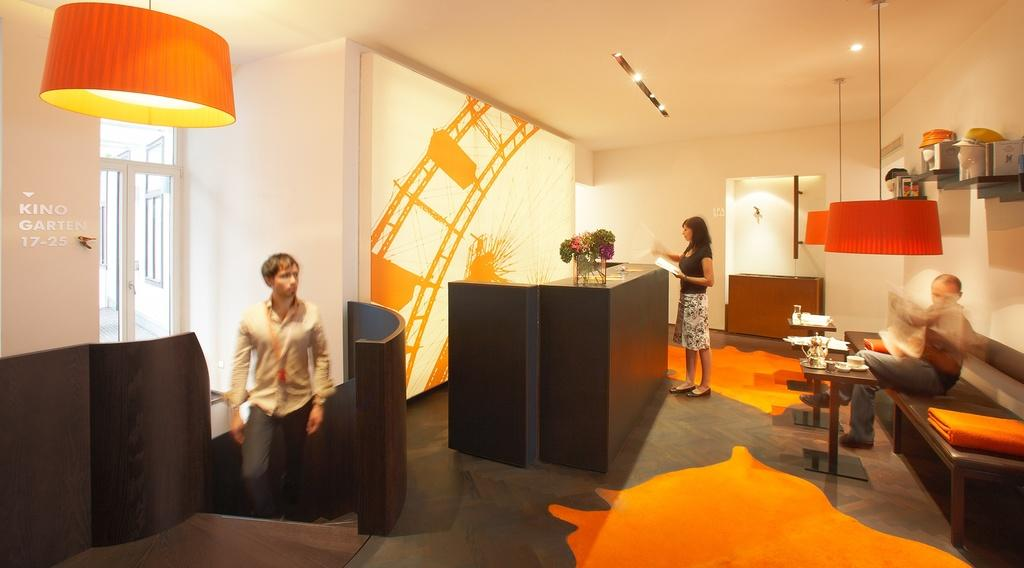What is the person standing in the image doing? The person standing in the image is holding a paper. Can you describe the other people in the image? There is a person sitting on a bench and a person walking in the image. What can be seen in the background of the image? There is a wall in the image. What is the source of light in the image? There is a light in the image. What is on the table in the image? There is a kettle and a cup on the table. How many pigs are visible in the image? There are no pigs present in the image. What type of tin is being used to hold the cup in the image? There is no tin present in the image; the cup is on the table. 